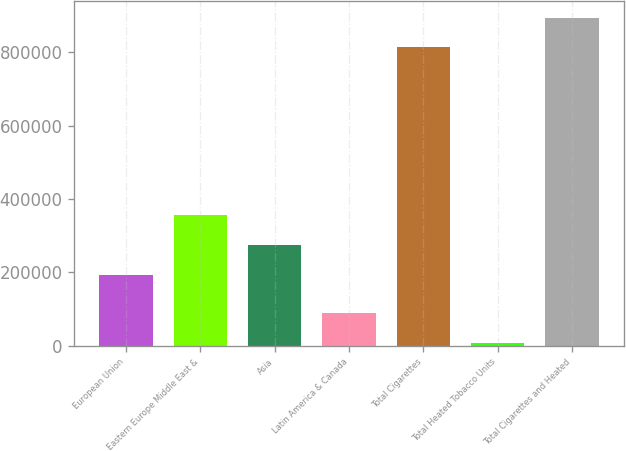<chart> <loc_0><loc_0><loc_500><loc_500><bar_chart><fcel>European Union<fcel>Eastern Europe Middle East &<fcel>Asia<fcel>Latin America & Canada<fcel>Total Cigarettes<fcel>Total Heated Tobacco Units<fcel>Total Cigarettes and Heated<nl><fcel>193586<fcel>356175<fcel>274881<fcel>88688.6<fcel>812946<fcel>7394<fcel>894241<nl></chart> 